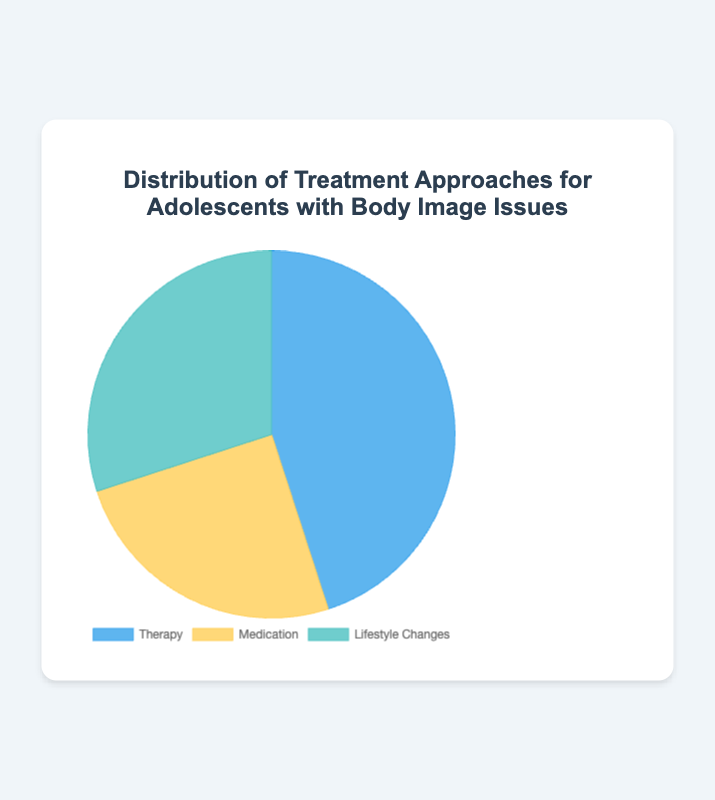What percentage of adolescents receive therapy as their treatment approach? The pie chart shows three types of treatment approaches. By looking at the segment labeled "Therapy," we see it comprises 45% of the pie chart.
Answer: 45% Which treatment approach is the least common among adolescents with body image issues? The pie chart shows three segments. The smallest segment is labeled "Medication," indicating that this is the least common treatment approach.
Answer: Medication What is the combined percentage of adolescents using therapy and lifestyle changes? The pie chart shows 45% for Therapy and 30% for Lifestyle Changes. Adding these together, 45% + 30% = 75%.
Answer: 75% How does the percentage of adolescents receiving lifestyle changes compare to medication? The pie chart shows that Lifestyle Changes account for 30% and Medication for 25%. Lifestyle Changes have a 5% higher percentage than Medication.
Answer: Lifestyle Changes is 5% higher Which segment in the pie chart is depicted in blue? The pie chart uses different colors for each segment. The segment depicted in blue represents Therapy.
Answer: Therapy Calculate the difference in percentage between the most and least common treatment approaches. The most common treatment approach is Therapy at 45%, and the least common is Medication at 25%. The difference is 45% - 25% = 20%.
Answer: 20% What can you infer about the total percentage covered by the pie chart? A pie chart typically represents the whole circle as 100%. Summing the provided percentages, 45% + 25% + 30% = 100%. This confirms the pie chart covers the entire population represented.
Answer: 100% If the total number of adolescents is 200, how many receive lifestyle changes? Lifestyle Changes account for 30%. To find this number, calculate 30% of 200, which is 0.30 * 200 = 60 adolescents.
Answer: 60 Are therapy and medication approaches equally common? By examining the individual segments, Therapy is 45% and Medication is 25%. These percentages are not equal.
Answer: No 